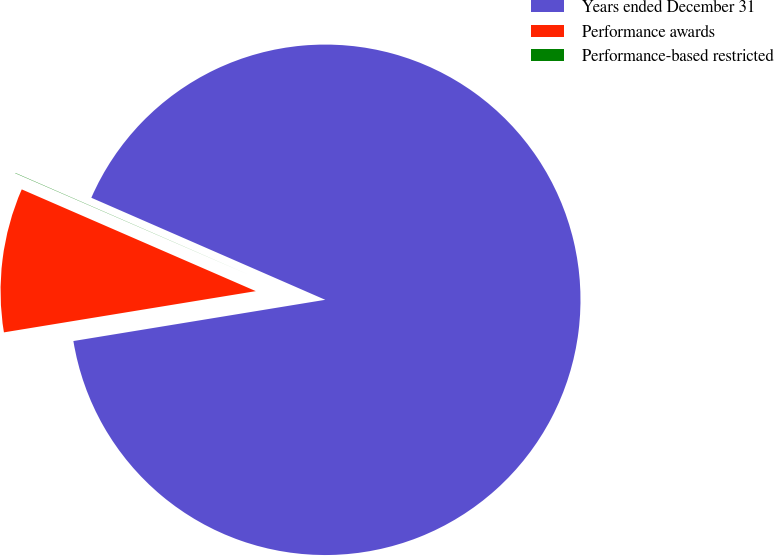Convert chart to OTSL. <chart><loc_0><loc_0><loc_500><loc_500><pie_chart><fcel>Years ended December 31<fcel>Performance awards<fcel>Performance-based restricted<nl><fcel>90.87%<fcel>9.11%<fcel>0.02%<nl></chart> 